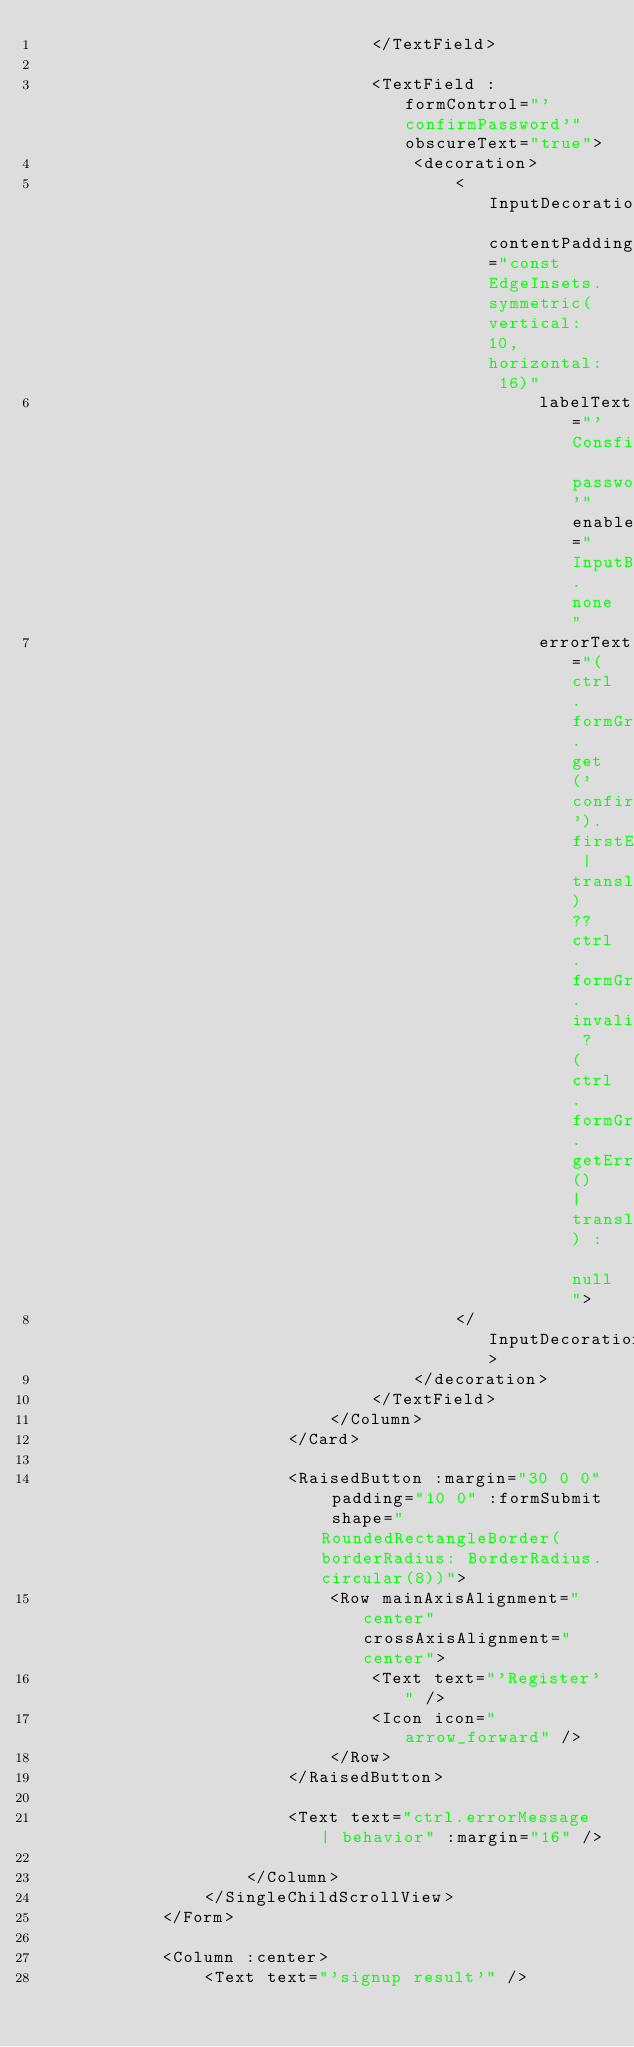Convert code to text. <code><loc_0><loc_0><loc_500><loc_500><_XML_>                                </TextField>
                                
                                <TextField :formControl="'confirmPassword'" obscureText="true">
                                    <decoration>
                                        <InputDecoration contentPadding="const EdgeInsets.symmetric(vertical: 10, horizontal: 16)"
                                                labelText="'Consfirm password'" enabledBorder="InputBorder.none"
                                                errorText="(ctrl.formGroup.get('confirmPassword').firstErrorIfTouched | translate) ?? ctrl.formGroup.invalid ? (ctrl.formGroup.getError() | translate) : null">
                                        </InputDecoration>
                                    </decoration>
                                </TextField>
                            </Column>
                        </Card>

                        <RaisedButton :margin="30 0 0" padding="10 0" :formSubmit shape="RoundedRectangleBorder(borderRadius: BorderRadius.circular(8))">
                            <Row mainAxisAlignment="center" crossAxisAlignment="center">
                                <Text text="'Register'" />
                                <Icon icon="arrow_forward" />
                            </Row>
                        </RaisedButton>
                        
                        <Text text="ctrl.errorMessage | behavior" :margin="16" />

                    </Column>
                </SingleChildScrollView>
            </Form>

            <Column :center>
                <Text text="'signup result'" /></code> 